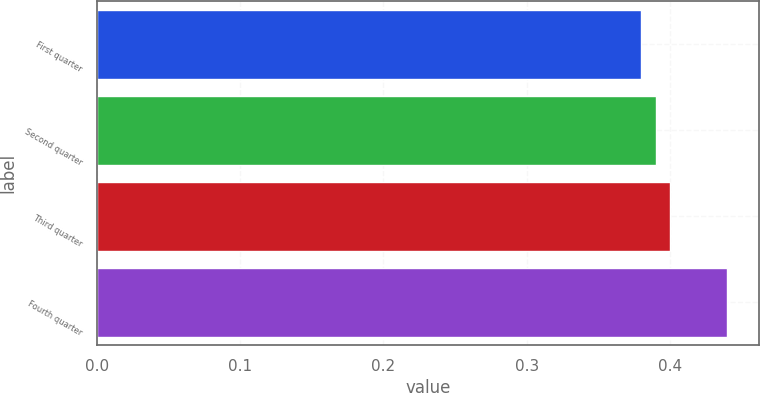Convert chart. <chart><loc_0><loc_0><loc_500><loc_500><bar_chart><fcel>First quarter<fcel>Second quarter<fcel>Third quarter<fcel>Fourth quarter<nl><fcel>0.38<fcel>0.39<fcel>0.4<fcel>0.44<nl></chart> 